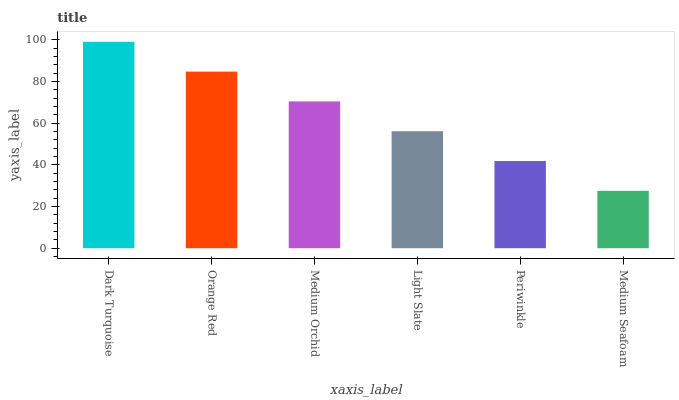Is Medium Seafoam the minimum?
Answer yes or no. Yes. Is Dark Turquoise the maximum?
Answer yes or no. Yes. Is Orange Red the minimum?
Answer yes or no. No. Is Orange Red the maximum?
Answer yes or no. No. Is Dark Turquoise greater than Orange Red?
Answer yes or no. Yes. Is Orange Red less than Dark Turquoise?
Answer yes or no. Yes. Is Orange Red greater than Dark Turquoise?
Answer yes or no. No. Is Dark Turquoise less than Orange Red?
Answer yes or no. No. Is Medium Orchid the high median?
Answer yes or no. Yes. Is Light Slate the low median?
Answer yes or no. Yes. Is Dark Turquoise the high median?
Answer yes or no. No. Is Periwinkle the low median?
Answer yes or no. No. 